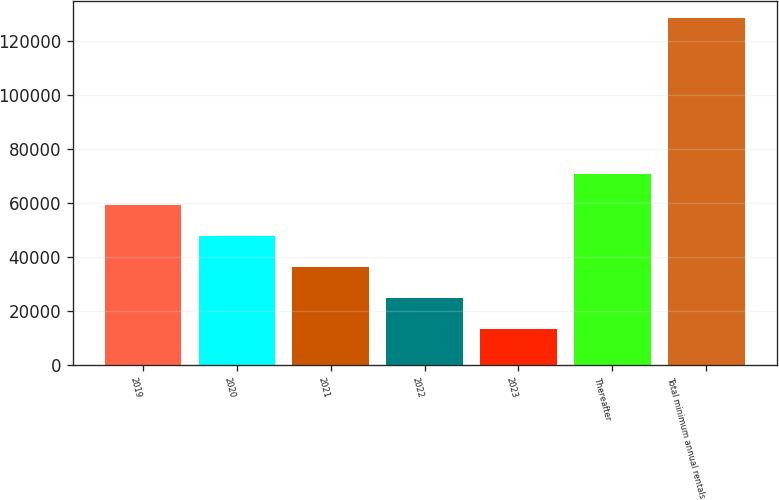Convert chart to OTSL. <chart><loc_0><loc_0><loc_500><loc_500><bar_chart><fcel>2019<fcel>2020<fcel>2021<fcel>2022<fcel>2023<fcel>Thereafter<fcel>Total minimum annual rentals<nl><fcel>59497.2<fcel>47988.4<fcel>36479.6<fcel>24970.8<fcel>13462<fcel>71006<fcel>128550<nl></chart> 